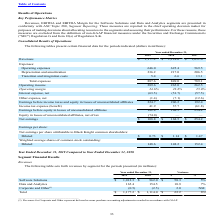According to Black Knight Financial Services's financial document, What did Revenues for Corporate and Other represent? deferred revenue purchase accounting adjustments recorded in accordance with GAAP.. The document states: "___ (1) Revenues for Corporate and Other represent deferred revenue purchase accounting adjustments recorded in accordance with GAAP...." Also, What was the total revenue in 2019? According to the financial document, 1,177.2 (in millions). The relevant text states: "Revenues $ 1,177.2 $ 1,114.0 $ 1,051.6..." Also, What was the dollar variance for software solutions? According to the financial document, 50.3 (in millions). The relevant text states: "Software Solutions $ 1,012.3 $ 962.0 $ 50.3 5%..." Also, How many years did revenue from Data and Analytics exceed $150 million? Counting the relevant items in the document: 2019, 2018, I find 2 instances. The key data points involved are: 2018, 2019. Additionally, Which years did revenue from Software Solutions exceed $1,000 million? According to the financial document, 2019. The relevant text states: "2019 2018 $ %..." Also, can you calculate: What was the average total revenue between 2018 and 2019? To answer this question, I need to perform calculations using the financial data. The calculation is: (1,177.2+1,114.0)/2, which equals 1145.6 (in millions). This is based on the information: "Revenues $ 1,177.2 $ 1,114.0 $ 1,051.6 Revenues $ 1,177.2 $ 1,114.0 $ 1,051.6..." The key data points involved are: 1,114.0, 1,177.2. 